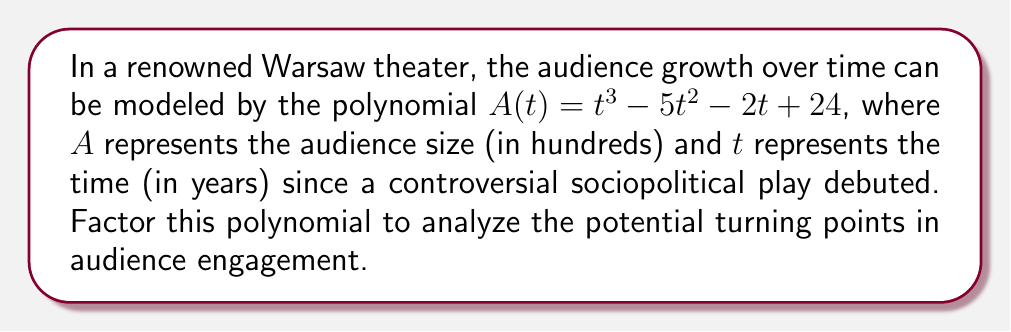Help me with this question. To factor this polynomial, we'll follow these steps:

1) First, let's check if there are any rational roots using the rational root theorem. The possible rational roots are the factors of the constant term: $\pm 1, \pm 2, \pm 3, \pm 4, \pm 6, \pm 8, \pm 12, \pm 24$

2) Testing these values, we find that $t = 4$ is a root. So $(t - 4)$ is a factor.

3) Divide the polynomial by $(t - 4)$:

   $$(t^3 - 5t^2 - 2t + 24) \div (t - 4) = t^2 - t - 6$$

4) Now we need to factor $t^2 - t - 6$. This is a quadratic equation.

5) For a quadratic in the form $at^2 + bt + c$, we look for two numbers that multiply to $ac$ and add to $b$.
   Here, $a = 1$, $b = -1$, and $c = -6$.
   We need two numbers that multiply to $-6$ and add to $-1$.
   These numbers are $-3$ and $2$.

6) So, $t^2 - t - 6 = (t - 3)(t + 2)$

7) Combining all factors:

   $$A(t) = (t - 4)(t - 3)(t + 2)$$

This factorization reveals that the audience size could potentially have turning points at $t = 4$, $t = 3$, and $t = -2$ years, which could correspond to significant events or changes in the theater's sociopolitical narrative.
Answer: $A(t) = (t - 4)(t - 3)(t + 2)$ 